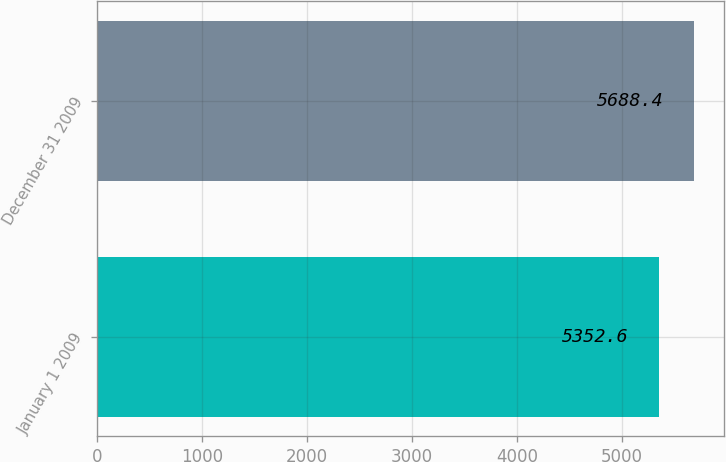<chart> <loc_0><loc_0><loc_500><loc_500><bar_chart><fcel>January 1 2009<fcel>December 31 2009<nl><fcel>5352.6<fcel>5688.4<nl></chart> 